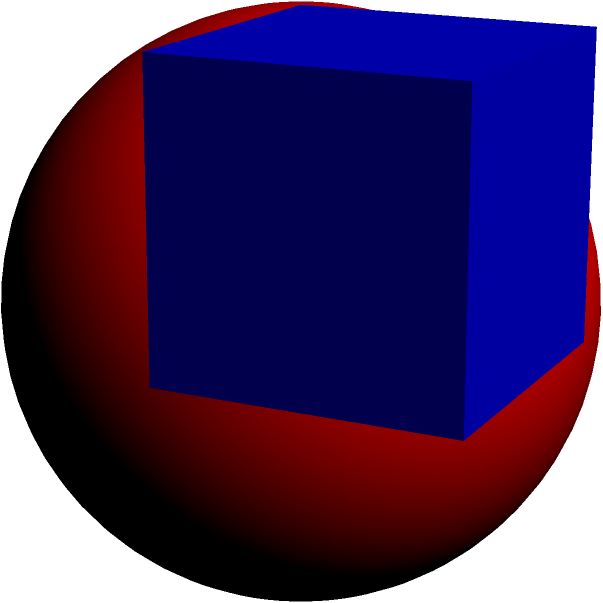In your work supporting trauma victims, you often use visual aids to explain concepts. You have a cube-shaped stress ball with a side length of 10 cm, and inside it is a spherical core. If the sphere touches all sides of the cube, what is the surface area of the spherical core? Round your answer to the nearest square centimeter. Let's approach this step-by-step:

1) In a cube with a sphere inscribed within it, the diameter of the sphere is equal to the side length of the cube. In this case, the side length of the cube is 10 cm.

2) Therefore, the diameter of the sphere is 10 cm, and its radius is 5 cm.

3) The formula for the surface area of a sphere is:
   $$A = 4\pi r^2$$

   Where $r$ is the radius of the sphere.

4) Substituting $r = 5$ cm into the formula:
   $$A = 4\pi (5\text{ cm})^2$$

5) Simplify:
   $$A = 4\pi (25\text{ cm}^2) = 100\pi\text{ cm}^2$$

6) Calculate:
   $$A \approx 314.16\text{ cm}^2$$

7) Rounding to the nearest square centimeter:
   $$A \approx 314\text{ cm}^2$$
Answer: 314 cm² 